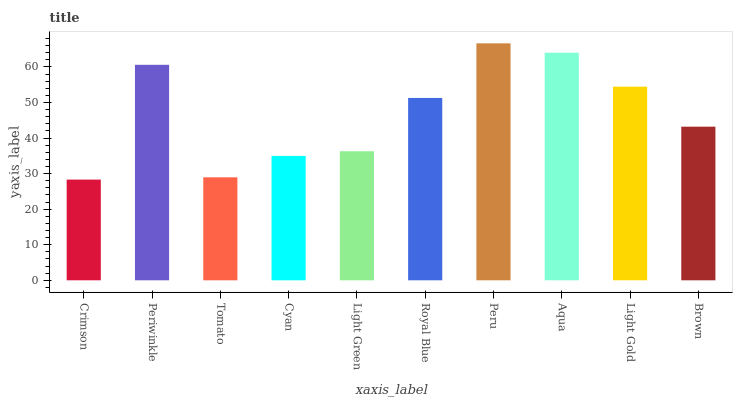Is Crimson the minimum?
Answer yes or no. Yes. Is Peru the maximum?
Answer yes or no. Yes. Is Periwinkle the minimum?
Answer yes or no. No. Is Periwinkle the maximum?
Answer yes or no. No. Is Periwinkle greater than Crimson?
Answer yes or no. Yes. Is Crimson less than Periwinkle?
Answer yes or no. Yes. Is Crimson greater than Periwinkle?
Answer yes or no. No. Is Periwinkle less than Crimson?
Answer yes or no. No. Is Royal Blue the high median?
Answer yes or no. Yes. Is Brown the low median?
Answer yes or no. Yes. Is Aqua the high median?
Answer yes or no. No. Is Peru the low median?
Answer yes or no. No. 